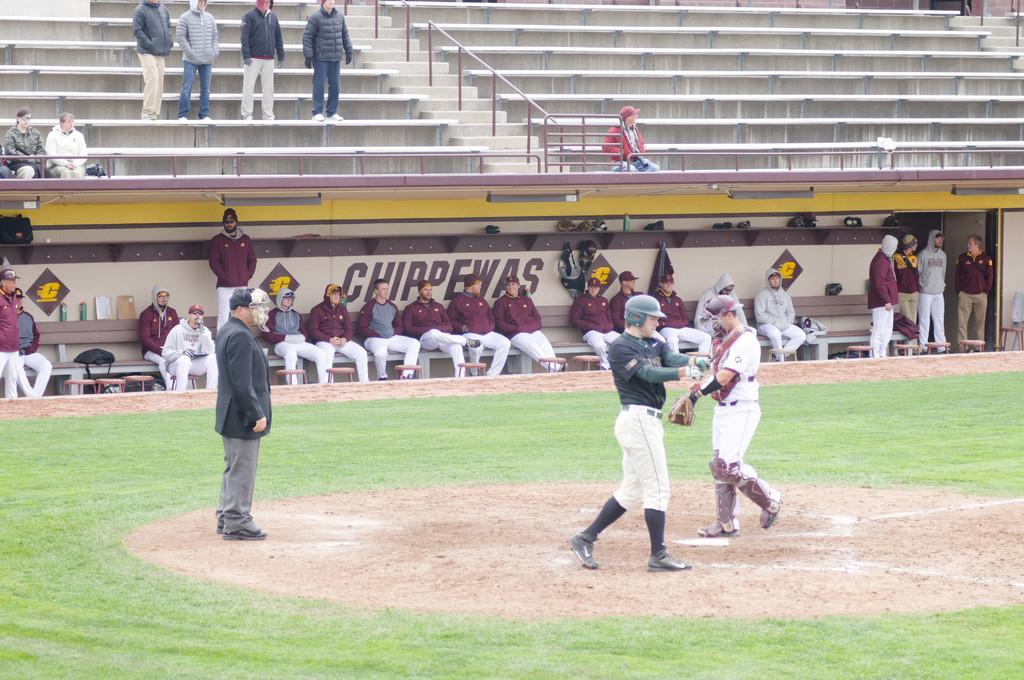<image>
Describe the image concisely. Several baseball players are sitting on a bench wit hthe name chippewas behind them. 